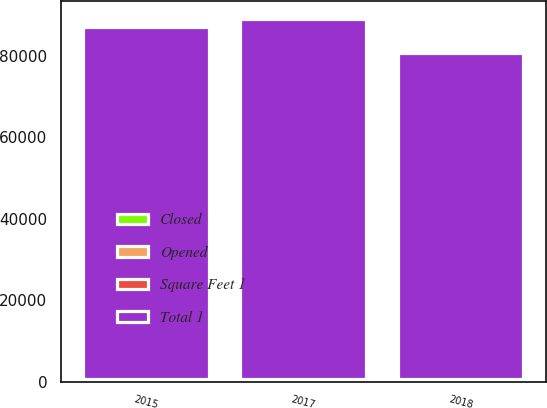<chart> <loc_0><loc_0><loc_500><loc_500><stacked_bar_chart><ecel><fcel>2015<fcel>2017<fcel>2018<nl><fcel>Square Feet 1<fcel>16<fcel>9<fcel>4<nl><fcel>Opened<fcel>1<fcel>4<fcel>67<nl><fcel>Closed<fcel>647<fcel>660<fcel>597<nl><fcel>Total 1<fcel>86510<fcel>88376<fcel>80068<nl></chart> 